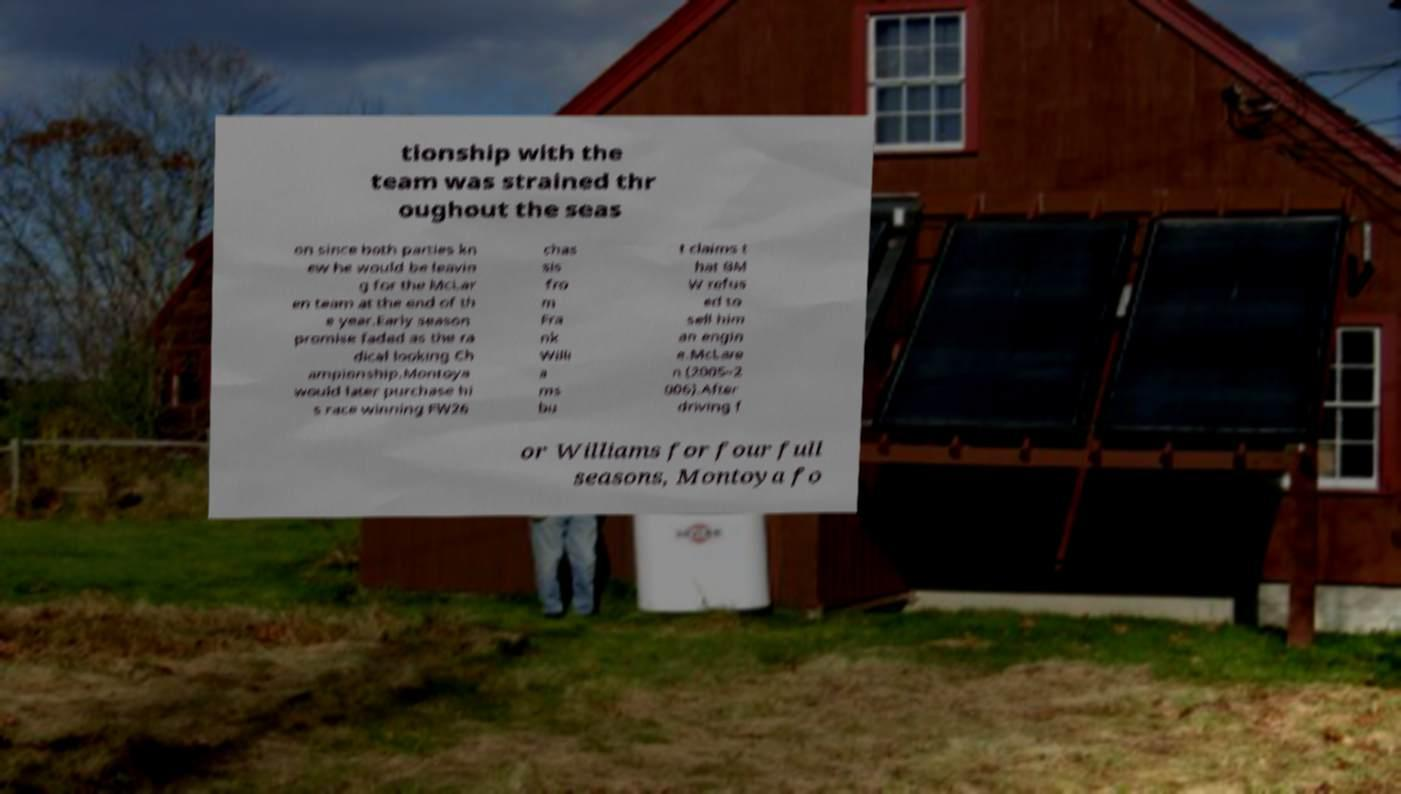Could you extract and type out the text from this image? tionship with the team was strained thr oughout the seas on since both parties kn ew he would be leavin g for the McLar en team at the end of th e year.Early season promise faded as the ra dical looking Ch ampionship.Montoya would later purchase hi s race winning FW26 chas sis fro m Fra nk Willi a ms bu t claims t hat BM W refus ed to sell him an engin e.McLare n (2005–2 006).After driving f or Williams for four full seasons, Montoya fo 